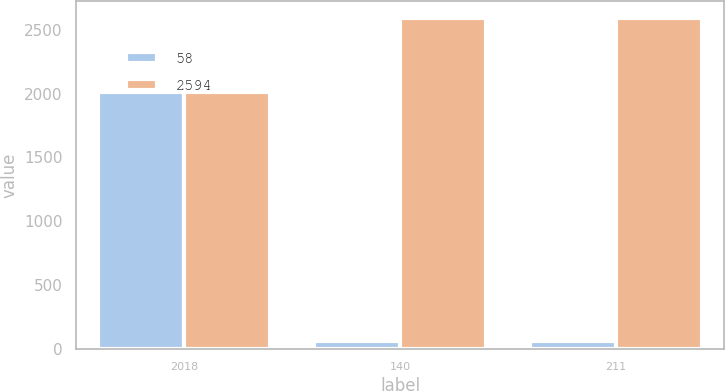Convert chart. <chart><loc_0><loc_0><loc_500><loc_500><stacked_bar_chart><ecel><fcel>2018<fcel>140<fcel>211<nl><fcel>58<fcel>2017<fcel>58<fcel>58<nl><fcel>2594<fcel>2016<fcel>2594<fcel>2594<nl></chart> 